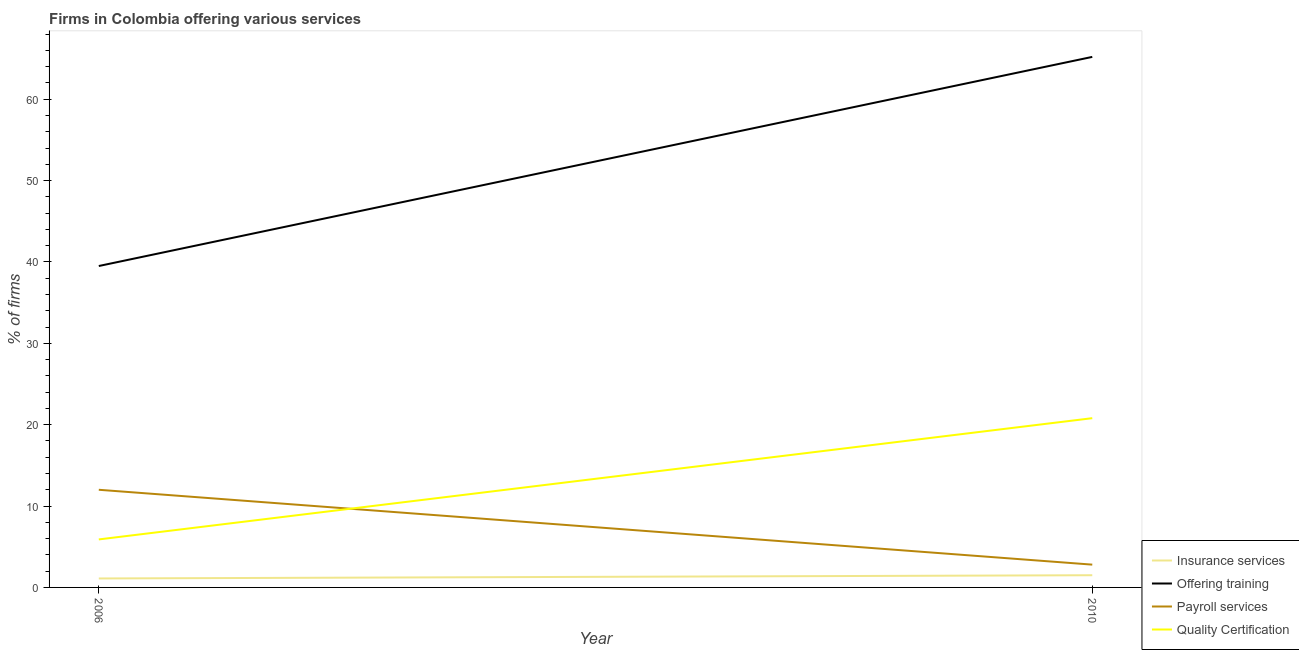What is the percentage of firms offering payroll services in 2006?
Your response must be concise. 12. Across all years, what is the maximum percentage of firms offering quality certification?
Provide a succinct answer. 20.8. In which year was the percentage of firms offering insurance services maximum?
Keep it short and to the point. 2010. In which year was the percentage of firms offering quality certification minimum?
Offer a very short reply. 2006. What is the total percentage of firms offering training in the graph?
Ensure brevity in your answer.  104.7. What is the difference between the percentage of firms offering payroll services in 2006 and that in 2010?
Your response must be concise. 9.2. What is the difference between the percentage of firms offering quality certification in 2006 and the percentage of firms offering insurance services in 2010?
Keep it short and to the point. 4.4. In the year 2010, what is the difference between the percentage of firms offering payroll services and percentage of firms offering insurance services?
Offer a terse response. 1.3. In how many years, is the percentage of firms offering quality certification greater than 66 %?
Keep it short and to the point. 0. What is the ratio of the percentage of firms offering insurance services in 2006 to that in 2010?
Ensure brevity in your answer.  0.73. Is the percentage of firms offering training in 2006 less than that in 2010?
Make the answer very short. Yes. In how many years, is the percentage of firms offering insurance services greater than the average percentage of firms offering insurance services taken over all years?
Your answer should be compact. 1. Is it the case that in every year, the sum of the percentage of firms offering training and percentage of firms offering quality certification is greater than the sum of percentage of firms offering insurance services and percentage of firms offering payroll services?
Keep it short and to the point. No. Is the percentage of firms offering insurance services strictly greater than the percentage of firms offering quality certification over the years?
Offer a very short reply. No. How many lines are there?
Give a very brief answer. 4. How many years are there in the graph?
Provide a short and direct response. 2. What is the difference between two consecutive major ticks on the Y-axis?
Give a very brief answer. 10. Are the values on the major ticks of Y-axis written in scientific E-notation?
Give a very brief answer. No. Does the graph contain grids?
Keep it short and to the point. No. How many legend labels are there?
Your response must be concise. 4. What is the title of the graph?
Provide a short and direct response. Firms in Colombia offering various services . What is the label or title of the X-axis?
Your response must be concise. Year. What is the label or title of the Y-axis?
Offer a very short reply. % of firms. What is the % of firms of Insurance services in 2006?
Offer a terse response. 1.1. What is the % of firms in Offering training in 2006?
Give a very brief answer. 39.5. What is the % of firms of Payroll services in 2006?
Give a very brief answer. 12. What is the % of firms of Quality Certification in 2006?
Give a very brief answer. 5.9. What is the % of firms of Offering training in 2010?
Ensure brevity in your answer.  65.2. What is the % of firms of Payroll services in 2010?
Ensure brevity in your answer.  2.8. What is the % of firms of Quality Certification in 2010?
Offer a very short reply. 20.8. Across all years, what is the maximum % of firms in Offering training?
Make the answer very short. 65.2. Across all years, what is the maximum % of firms in Payroll services?
Ensure brevity in your answer.  12. Across all years, what is the maximum % of firms in Quality Certification?
Keep it short and to the point. 20.8. Across all years, what is the minimum % of firms in Insurance services?
Your response must be concise. 1.1. Across all years, what is the minimum % of firms of Offering training?
Make the answer very short. 39.5. Across all years, what is the minimum % of firms in Quality Certification?
Give a very brief answer. 5.9. What is the total % of firms in Insurance services in the graph?
Provide a short and direct response. 2.6. What is the total % of firms of Offering training in the graph?
Give a very brief answer. 104.7. What is the total % of firms in Payroll services in the graph?
Keep it short and to the point. 14.8. What is the total % of firms in Quality Certification in the graph?
Offer a terse response. 26.7. What is the difference between the % of firms in Insurance services in 2006 and that in 2010?
Offer a terse response. -0.4. What is the difference between the % of firms in Offering training in 2006 and that in 2010?
Keep it short and to the point. -25.7. What is the difference between the % of firms of Payroll services in 2006 and that in 2010?
Make the answer very short. 9.2. What is the difference between the % of firms in Quality Certification in 2006 and that in 2010?
Offer a very short reply. -14.9. What is the difference between the % of firms in Insurance services in 2006 and the % of firms in Offering training in 2010?
Provide a succinct answer. -64.1. What is the difference between the % of firms of Insurance services in 2006 and the % of firms of Payroll services in 2010?
Your answer should be compact. -1.7. What is the difference between the % of firms in Insurance services in 2006 and the % of firms in Quality Certification in 2010?
Keep it short and to the point. -19.7. What is the difference between the % of firms of Offering training in 2006 and the % of firms of Payroll services in 2010?
Make the answer very short. 36.7. What is the average % of firms in Insurance services per year?
Provide a succinct answer. 1.3. What is the average % of firms in Offering training per year?
Ensure brevity in your answer.  52.35. What is the average % of firms of Quality Certification per year?
Provide a succinct answer. 13.35. In the year 2006, what is the difference between the % of firms in Insurance services and % of firms in Offering training?
Provide a succinct answer. -38.4. In the year 2006, what is the difference between the % of firms in Insurance services and % of firms in Quality Certification?
Your response must be concise. -4.8. In the year 2006, what is the difference between the % of firms of Offering training and % of firms of Quality Certification?
Give a very brief answer. 33.6. In the year 2010, what is the difference between the % of firms of Insurance services and % of firms of Offering training?
Offer a terse response. -63.7. In the year 2010, what is the difference between the % of firms of Insurance services and % of firms of Payroll services?
Your answer should be very brief. -1.3. In the year 2010, what is the difference between the % of firms in Insurance services and % of firms in Quality Certification?
Provide a succinct answer. -19.3. In the year 2010, what is the difference between the % of firms of Offering training and % of firms of Payroll services?
Provide a succinct answer. 62.4. In the year 2010, what is the difference between the % of firms of Offering training and % of firms of Quality Certification?
Keep it short and to the point. 44.4. In the year 2010, what is the difference between the % of firms in Payroll services and % of firms in Quality Certification?
Give a very brief answer. -18. What is the ratio of the % of firms of Insurance services in 2006 to that in 2010?
Give a very brief answer. 0.73. What is the ratio of the % of firms in Offering training in 2006 to that in 2010?
Your response must be concise. 0.61. What is the ratio of the % of firms in Payroll services in 2006 to that in 2010?
Offer a very short reply. 4.29. What is the ratio of the % of firms in Quality Certification in 2006 to that in 2010?
Offer a very short reply. 0.28. What is the difference between the highest and the second highest % of firms of Insurance services?
Give a very brief answer. 0.4. What is the difference between the highest and the second highest % of firms of Offering training?
Keep it short and to the point. 25.7. What is the difference between the highest and the second highest % of firms of Quality Certification?
Provide a succinct answer. 14.9. What is the difference between the highest and the lowest % of firms in Insurance services?
Offer a very short reply. 0.4. What is the difference between the highest and the lowest % of firms of Offering training?
Your response must be concise. 25.7. What is the difference between the highest and the lowest % of firms of Payroll services?
Your response must be concise. 9.2. 